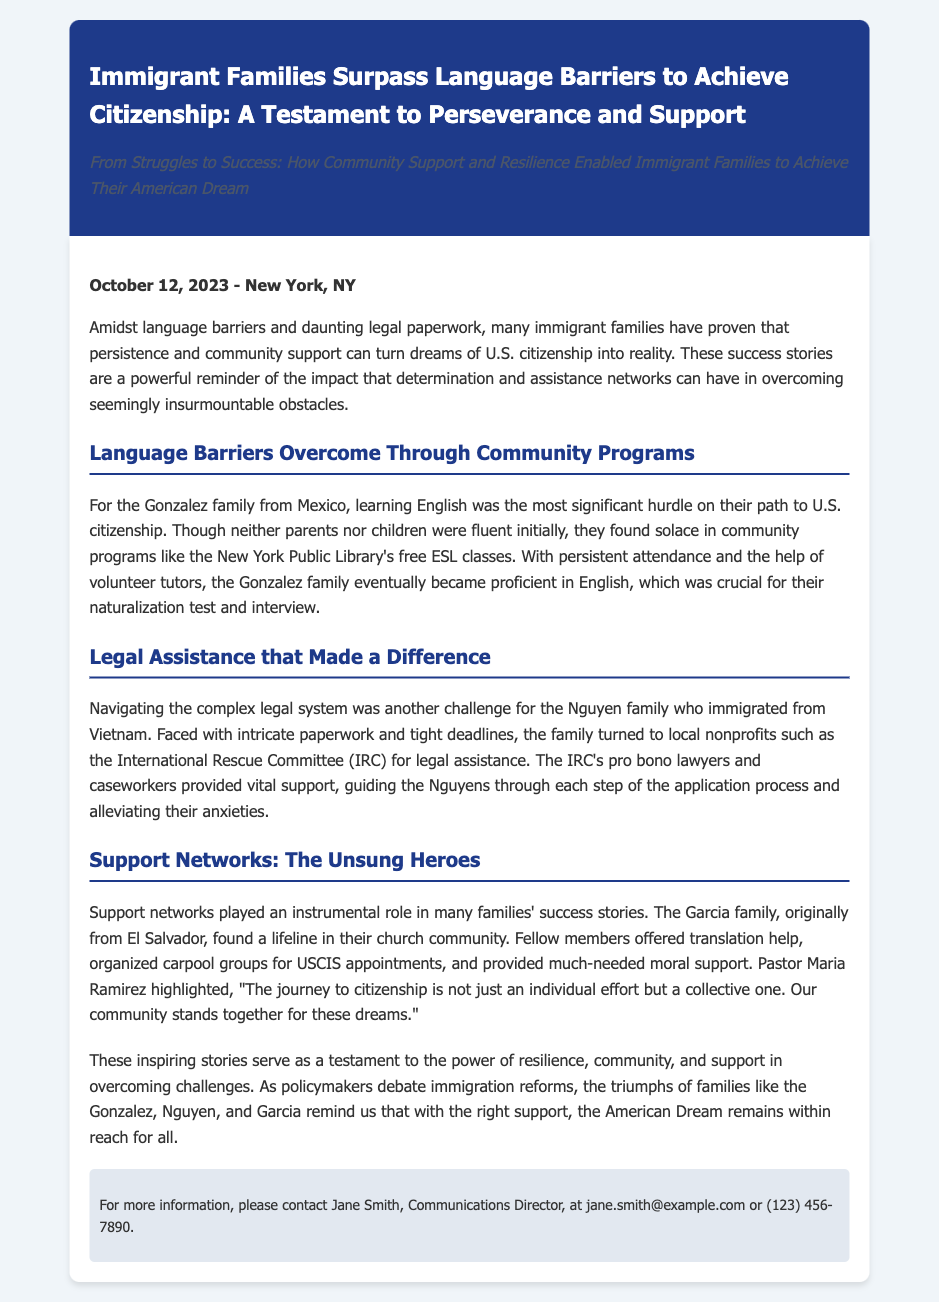What is the publication date of the press release? The publication date is located in the dateline section of the document.
Answer: October 12, 2023 Who is the communications director mentioned in the release? The communications director's name is stated in the contact section of the document.
Answer: Jane Smith What community program helped the Gonzalez family learn English? The specific community program is mentioned as part of how the Gonzalez family overcame language barriers.
Answer: New York Public Library's free ESL classes Which family received legal assistance from the International Rescue Committee? This information can be found in the section discussing legal assistance, specifying which family received help.
Answer: Nguyen family What role did Pastor Maria Ramirez play in the Garcia family's success? The document specifies the role of Pastor Maria Ramirez in connection with the Garcia family's community support.
Answer: Highlighted support How did support networks contribute to the citizenship journey? This question requires reasoning about the role of community support mentioned in the document.
Answer: Instrumental role What country did the Nguyen family immigrate from? The document specifies the origin of the Nguyen family in the context of their immigration story.
Answer: Vietnam What type of release is this document categorized as? The document type is indicated clearly in the title and format of the content.
Answer: Press release What is described as a collective effort in the journey to citizenship? This is related to the sentence detailing community support in citizenship journeys.
Answer: Community support 